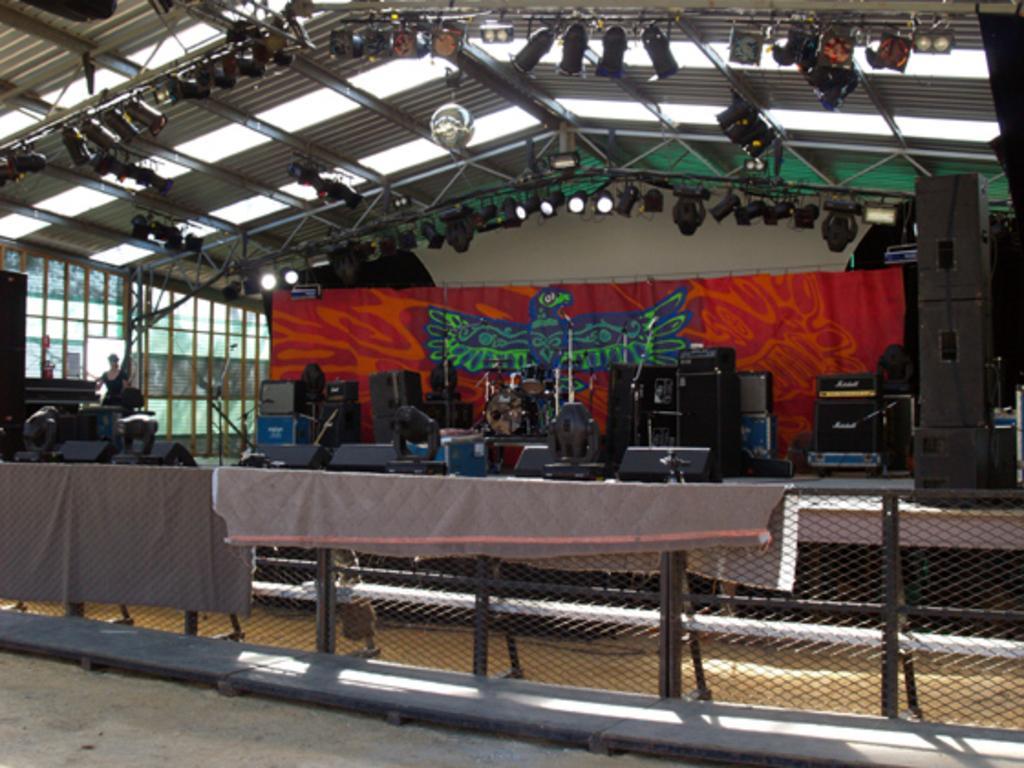Please provide a concise description of this image. In this image, I can see the clothes on a fence. There are objects on the stage. In the background, I can see a banner hanging. On the left side of the image, there is a person standing. At the top of the image, I can see the focus lights attached to the ceiling. 